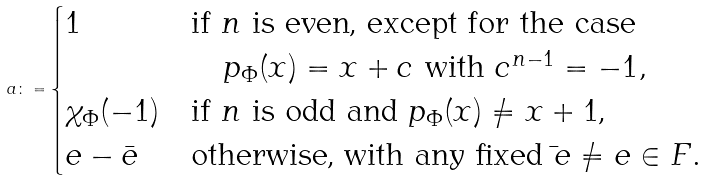Convert formula to latex. <formula><loc_0><loc_0><loc_500><loc_500>a \colon = \begin{cases} 1 & \text {if $n$ is even,   except for the   case} \\ & \quad p _ { \Phi } ( x ) = x + c \ \text {with } c ^ { n - 1 } = - 1 , \\ \chi _ { \Phi } ( - 1 ) & \text {if $n$ is odd and $p_{\Phi}(x)\ne x+1$,} \\ e - \bar { e } & \text {otherwise, with any fixed $\bar{ }e\ne e\in\mathbb{ }F$} . \end{cases}</formula> 